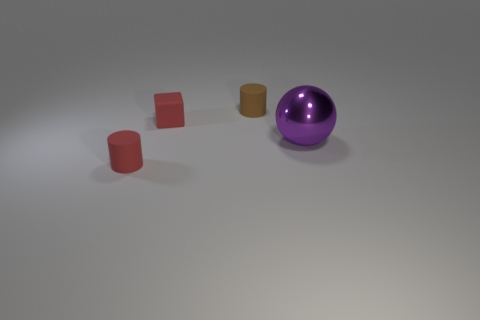Is there any other thing that has the same size as the shiny thing?
Give a very brief answer. No. Are there any other things that are made of the same material as the large sphere?
Keep it short and to the point. No. There is a small red thing that is right of the rubber cylinder that is on the left side of the tiny brown thing; what is its shape?
Keep it short and to the point. Cube. Is the shape of the thing to the right of the brown rubber cylinder the same as  the brown matte object?
Your answer should be compact. No. The object that is in front of the purple object is what color?
Give a very brief answer. Red. How many balls are either brown things or matte things?
Your answer should be compact. 0. There is a rubber object in front of the thing that is to the right of the tiny brown thing; what is its size?
Ensure brevity in your answer.  Small. Do the small cube and the small rubber cylinder behind the large purple metallic sphere have the same color?
Give a very brief answer. No. There is a red cube; how many big balls are behind it?
Ensure brevity in your answer.  0. Is the number of small cylinders less than the number of tiny blue metallic things?
Offer a terse response. No. 